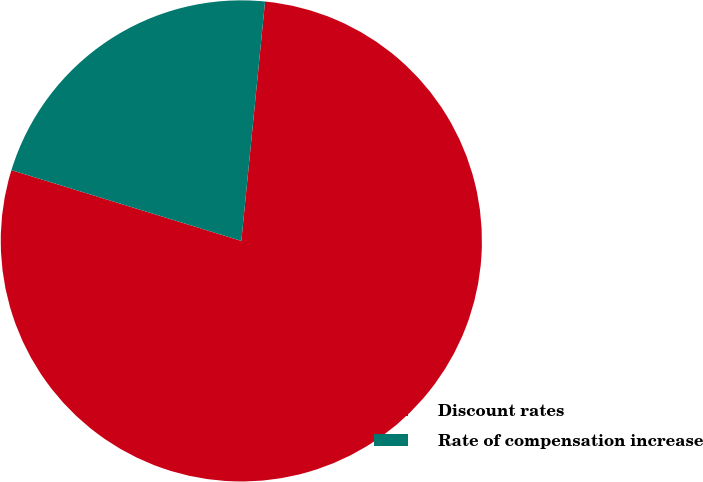<chart> <loc_0><loc_0><loc_500><loc_500><pie_chart><fcel>Discount rates<fcel>Rate of compensation increase<nl><fcel>78.18%<fcel>21.82%<nl></chart> 